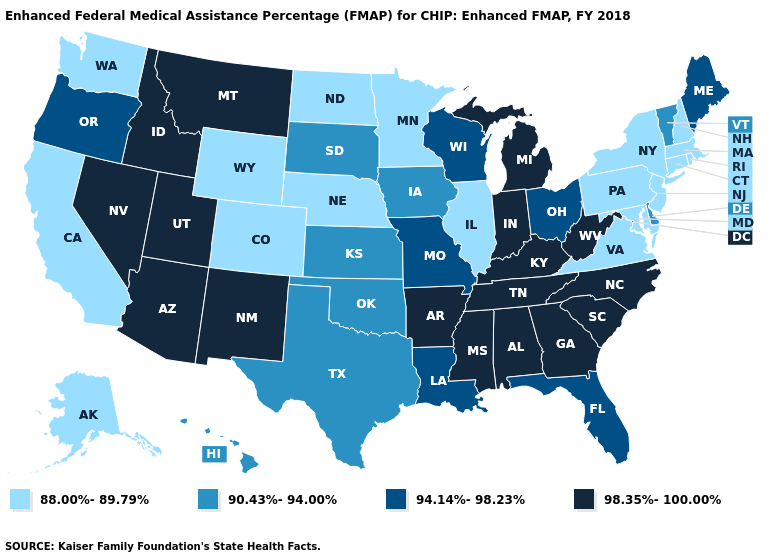What is the value of Illinois?
Concise answer only. 88.00%-89.79%. Among the states that border South Dakota , does Nebraska have the lowest value?
Be succinct. Yes. Name the states that have a value in the range 88.00%-89.79%?
Keep it brief. Alaska, California, Colorado, Connecticut, Illinois, Maryland, Massachusetts, Minnesota, Nebraska, New Hampshire, New Jersey, New York, North Dakota, Pennsylvania, Rhode Island, Virginia, Washington, Wyoming. Does Vermont have a higher value than New Jersey?
Write a very short answer. Yes. Does the map have missing data?
Keep it brief. No. What is the value of Virginia?
Be succinct. 88.00%-89.79%. What is the highest value in states that border Colorado?
Concise answer only. 98.35%-100.00%. What is the value of Kansas?
Short answer required. 90.43%-94.00%. Does Maryland have the lowest value in the USA?
Keep it brief. Yes. Name the states that have a value in the range 98.35%-100.00%?
Concise answer only. Alabama, Arizona, Arkansas, Georgia, Idaho, Indiana, Kentucky, Michigan, Mississippi, Montana, Nevada, New Mexico, North Carolina, South Carolina, Tennessee, Utah, West Virginia. Which states hav the highest value in the West?
Be succinct. Arizona, Idaho, Montana, Nevada, New Mexico, Utah. What is the lowest value in the Northeast?
Give a very brief answer. 88.00%-89.79%. Name the states that have a value in the range 90.43%-94.00%?
Short answer required. Delaware, Hawaii, Iowa, Kansas, Oklahoma, South Dakota, Texas, Vermont. Does Indiana have the highest value in the MidWest?
Give a very brief answer. Yes. Does Pennsylvania have the lowest value in the USA?
Give a very brief answer. Yes. 